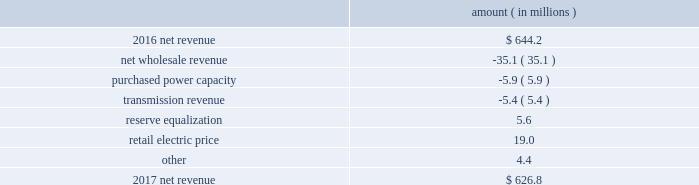Entergy texas , inc .
And subsidiaries management 2019s financial discussion and analysis results of operations net income 2017 compared to 2016 net income decreased $ 31.4 million primarily due to lower net revenue , higher depreciation and amortization expenses , higher other operation and maintenance expenses , and higher taxes other than income taxes .
2016 compared to 2015 net income increased $ 37.9 million primarily due to lower other operation and maintenance expenses , the asset write-off of its receivable associated with the spindletop gas storage facility in 2015 , and higher net revenue .
Net revenue 2017 compared to 2016 net revenue consists of operating revenues net of : 1 ) fuel , fuel-related expenses , and gas purchased for resale , 2 ) purchased power expenses , and 3 ) other regulatory charges .
Following is an analysis of the change in net revenue comparing 2017 to 2016 .
Amount ( in millions ) .
The net wholesale revenue variance is primarily due to lower net capacity revenues resulting from the termination of the purchased power agreements between entergy louisiana and entergy texas in august 2016 .
The purchased power capacity variance is primarily due to increased expenses due to capacity cost changes for ongoing purchased power capacity contracts .
The transmission revenue variance is primarily due to a decrease in the amount of transmission revenues allocated by miso .
The reserve equalization variance is due to the absence of reserve equalization expenses in 2017 as a result of entergy texas 2019s exit from the system agreement in august 2016 .
See note 2 to the financial statements for a discussion of the system agreement. .
What percent change did the drop in net wholesale revenue cause for 2017 net revenue? 
Computations: (35.1 / (626.8 + 35.1))
Answer: 0.05303. Entergy texas , inc .
And subsidiaries management 2019s financial discussion and analysis results of operations net income 2017 compared to 2016 net income decreased $ 31.4 million primarily due to lower net revenue , higher depreciation and amortization expenses , higher other operation and maintenance expenses , and higher taxes other than income taxes .
2016 compared to 2015 net income increased $ 37.9 million primarily due to lower other operation and maintenance expenses , the asset write-off of its receivable associated with the spindletop gas storage facility in 2015 , and higher net revenue .
Net revenue 2017 compared to 2016 net revenue consists of operating revenues net of : 1 ) fuel , fuel-related expenses , and gas purchased for resale , 2 ) purchased power expenses , and 3 ) other regulatory charges .
Following is an analysis of the change in net revenue comparing 2017 to 2016 .
Amount ( in millions ) .
The net wholesale revenue variance is primarily due to lower net capacity revenues resulting from the termination of the purchased power agreements between entergy louisiana and entergy texas in august 2016 .
The purchased power capacity variance is primarily due to increased expenses due to capacity cost changes for ongoing purchased power capacity contracts .
The transmission revenue variance is primarily due to a decrease in the amount of transmission revenues allocated by miso .
The reserve equalization variance is due to the absence of reserve equalization expenses in 2017 as a result of entergy texas 2019s exit from the system agreement in august 2016 .
See note 2 to the financial statements for a discussion of the system agreement. .
What was the ratio of the change in net revenue to the increase in net income in 2016? 
Computations: (644.2 / 37.9)
Answer: 16.99736. 